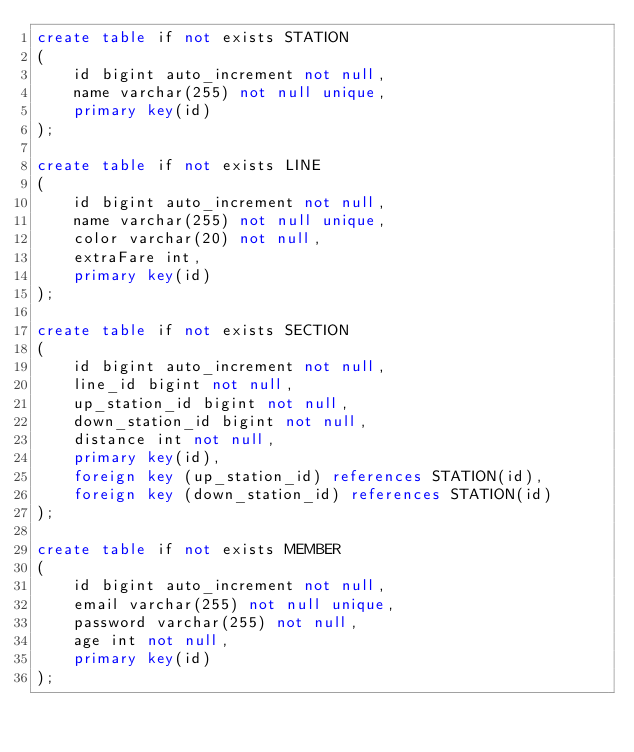Convert code to text. <code><loc_0><loc_0><loc_500><loc_500><_SQL_>create table if not exists STATION
(
    id bigint auto_increment not null,
    name varchar(255) not null unique,
    primary key(id)
);

create table if not exists LINE
(
    id bigint auto_increment not null,
    name varchar(255) not null unique,
    color varchar(20) not null,
    extraFare int,
    primary key(id)
);

create table if not exists SECTION
(
    id bigint auto_increment not null,
    line_id bigint not null,
    up_station_id bigint not null,
    down_station_id bigint not null,
    distance int not null,
    primary key(id),
    foreign key (up_station_id) references STATION(id),
    foreign key (down_station_id) references STATION(id)
);

create table if not exists MEMBER
(
    id bigint auto_increment not null,
    email varchar(255) not null unique,
    password varchar(255) not null,
    age int not null,
    primary key(id)
);
</code> 